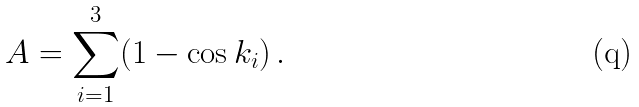<formula> <loc_0><loc_0><loc_500><loc_500>A = \sum _ { i = 1 } ^ { 3 } ( 1 - \cos k _ { i } ) \, .</formula> 